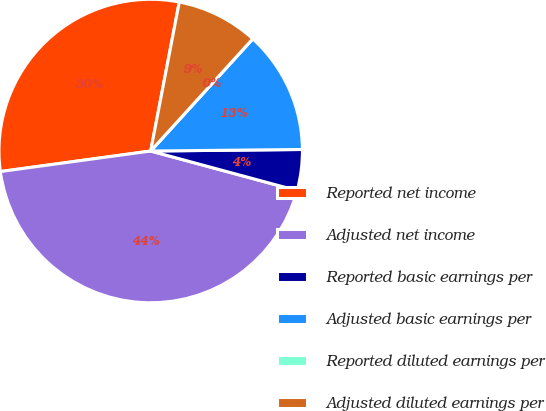<chart> <loc_0><loc_0><loc_500><loc_500><pie_chart><fcel>Reported net income<fcel>Adjusted net income<fcel>Reported basic earnings per<fcel>Adjusted basic earnings per<fcel>Reported diluted earnings per<fcel>Adjusted diluted earnings per<nl><fcel>30.18%<fcel>43.64%<fcel>4.36%<fcel>13.09%<fcel>0.0%<fcel>8.73%<nl></chart> 